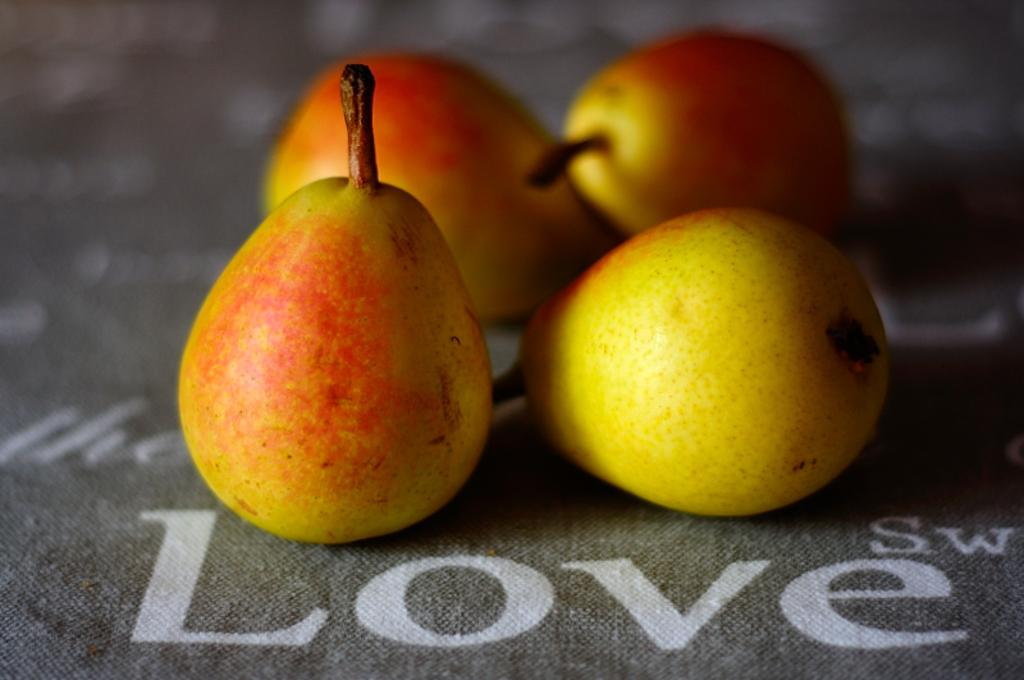What type of fruit is visible in the image? There are pear fruits in the image. Where are the pear fruits located? The pear fruits are on a sheet. What else can be seen on the sheet besides the pear fruits? There is text on the sheet. What type of quill is used to write the text on the sheet? There is no quill visible in the image, and the text appears to be printed or typed, not handwritten. 